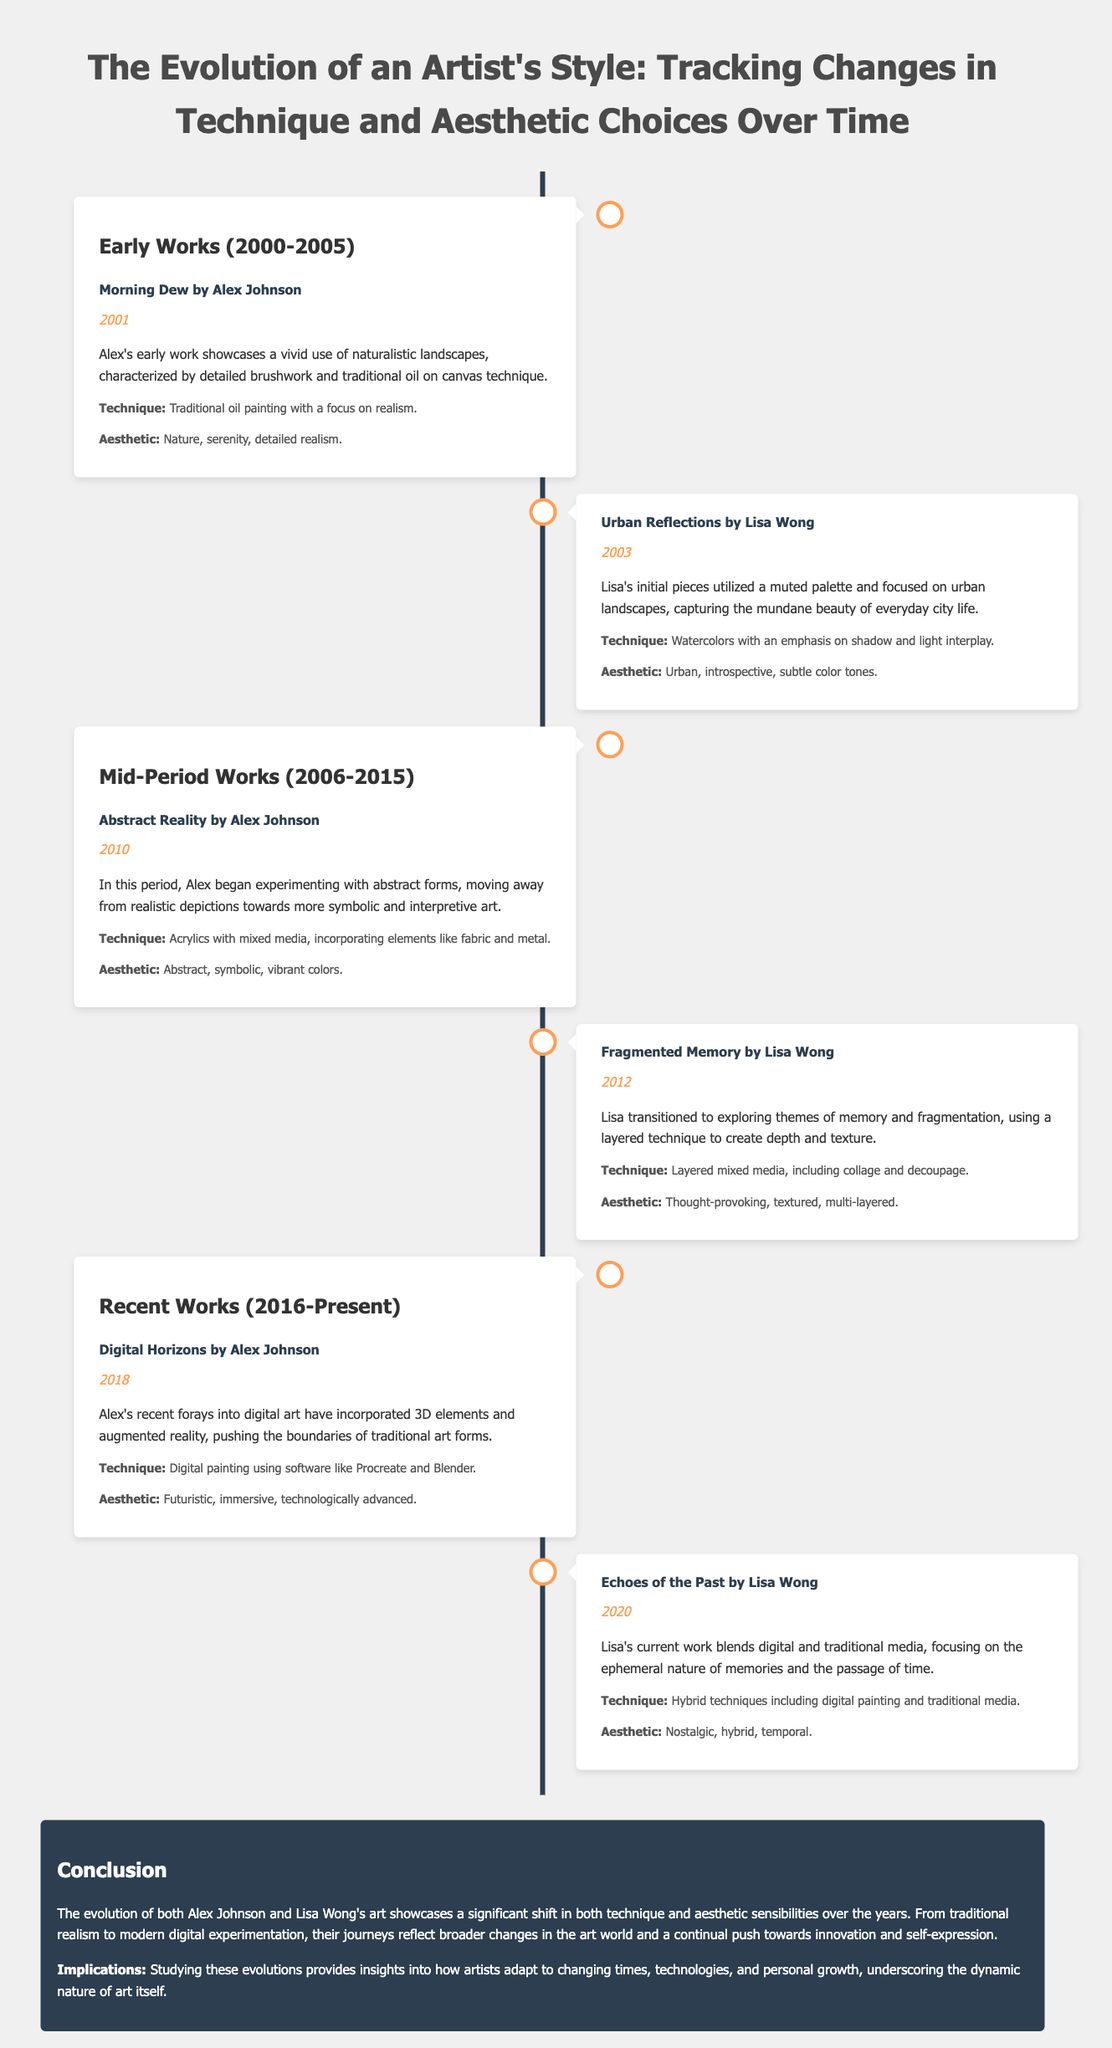What is the title of Alex Johnson's early work? The title of Alex Johnson's early work, which was painted in 2001, is "Morning Dew."
Answer: Morning Dew In which year was "Urban Reflections" created? "Urban Reflections" by Lisa Wong was created in 2003, according to the timeline.
Answer: 2003 What technique does Alex Johnson use in his recent work? In his recent work "Digital Horizons," Alex Johnson uses digital painting with software like Procreate and Blender.
Answer: Digital painting What major change occurred in Alex Johnson's aesthetic from the early works to the recent works? Alex Johnson transitioned from a nature and serenity aesthetic to a futuristic and immersive aesthetic.
Answer: Futuristic, immersive What is the primary theme of Lisa Wong's recent piece "Echoes of the Past"? The primary theme of "Echoes of the Past" is the ephemeral nature of memories and the passage of time.
Answer: Ephemeral nature of memories Which artist used mixed media involving layering in their mid-period work? Lisa Wong used layered mixed media techniques in her mid-period work "Fragmented Memory."
Answer: Lisa Wong What color palette did Lisa Wong utilize in her early urban landscapes? Lisa Wong used a muted palette in her early urban landscapes.
Answer: Muted palette How many years are covered in the early works period? The early works period spans from 2000 to 2005, covering a total of 5 years.
Answer: 5 years 